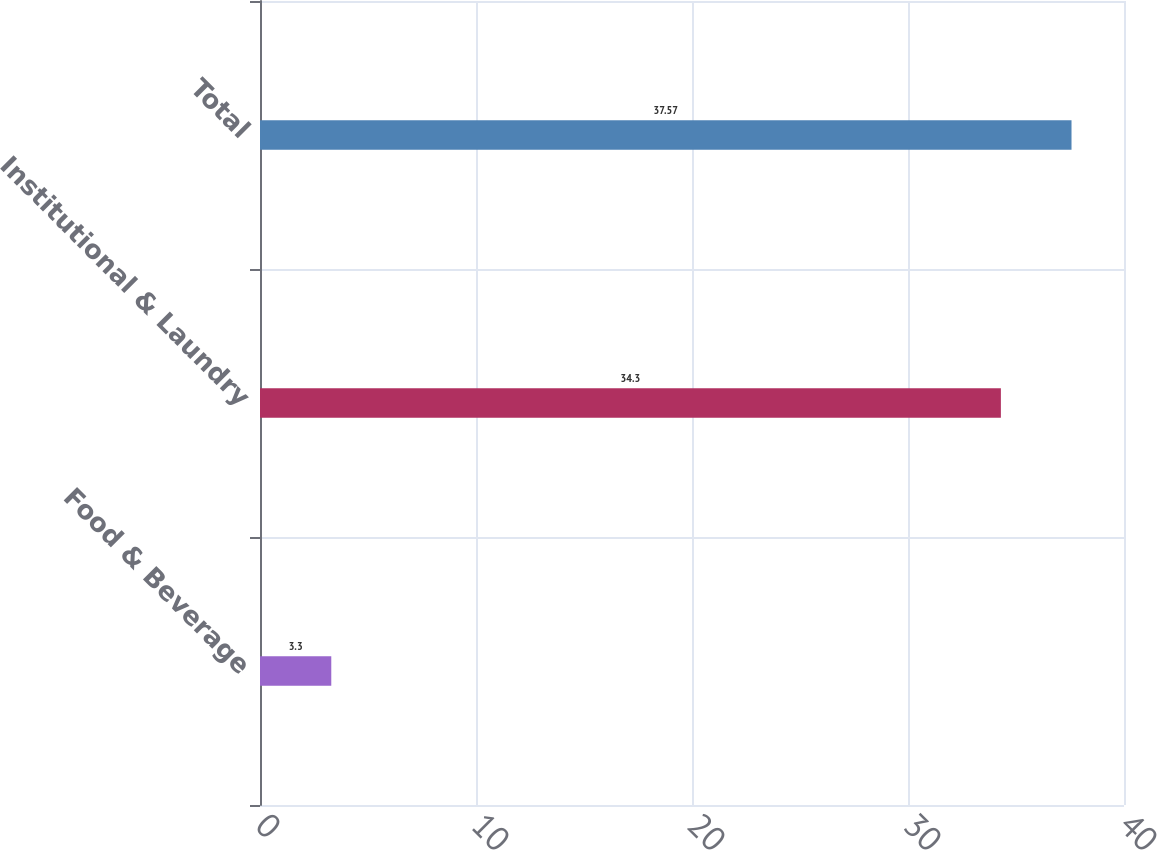Convert chart. <chart><loc_0><loc_0><loc_500><loc_500><bar_chart><fcel>Food & Beverage<fcel>Institutional & Laundry<fcel>Total<nl><fcel>3.3<fcel>34.3<fcel>37.57<nl></chart> 